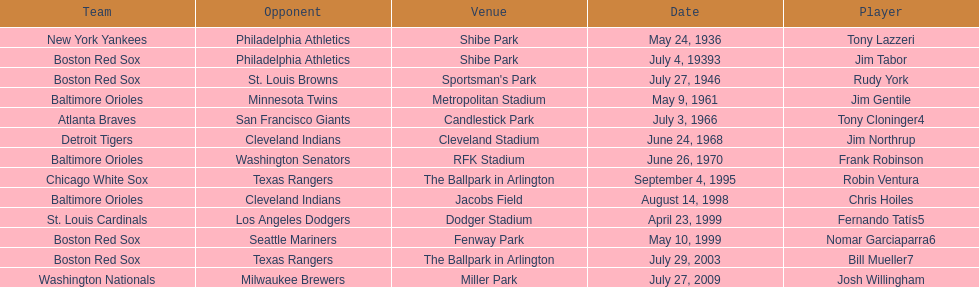What was the name of the last person to accomplish this up to date? Josh Willingham. 